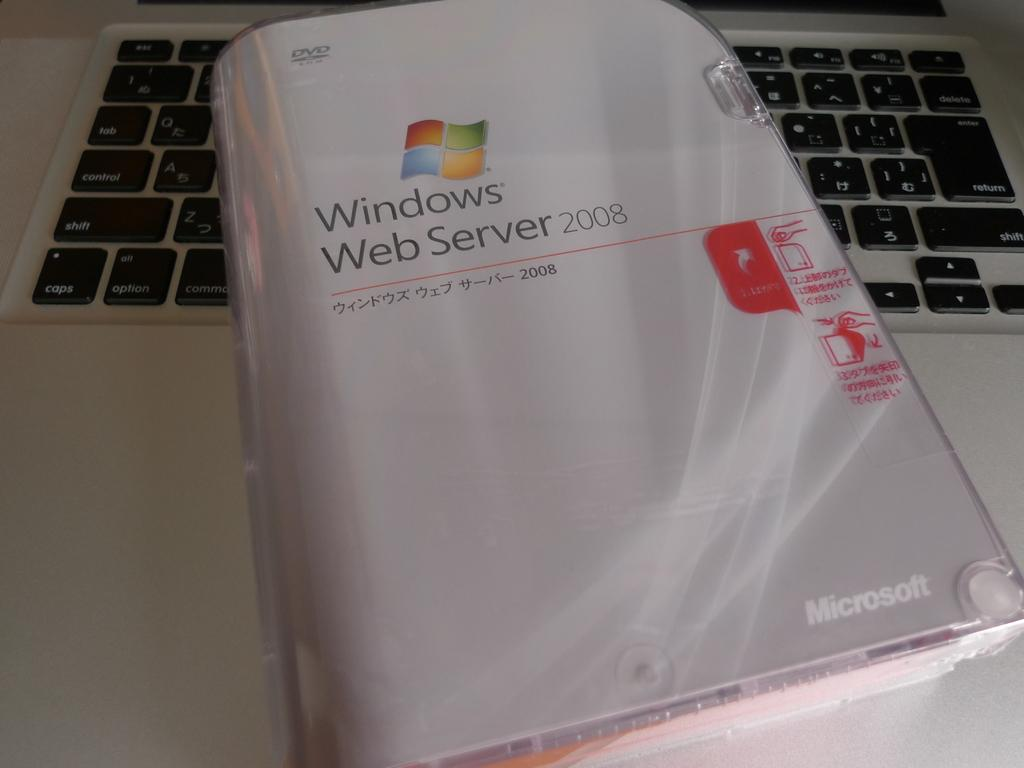<image>
Give a short and clear explanation of the subsequent image. The Windows Web Server 2008 manual also includes a DVD. 